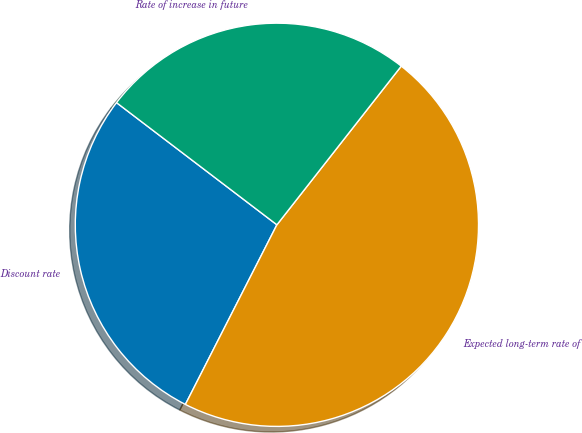Convert chart. <chart><loc_0><loc_0><loc_500><loc_500><pie_chart><fcel>Discount rate<fcel>Expected long-term rate of<fcel>Rate of increase in future<nl><fcel>27.86%<fcel>46.92%<fcel>25.22%<nl></chart> 